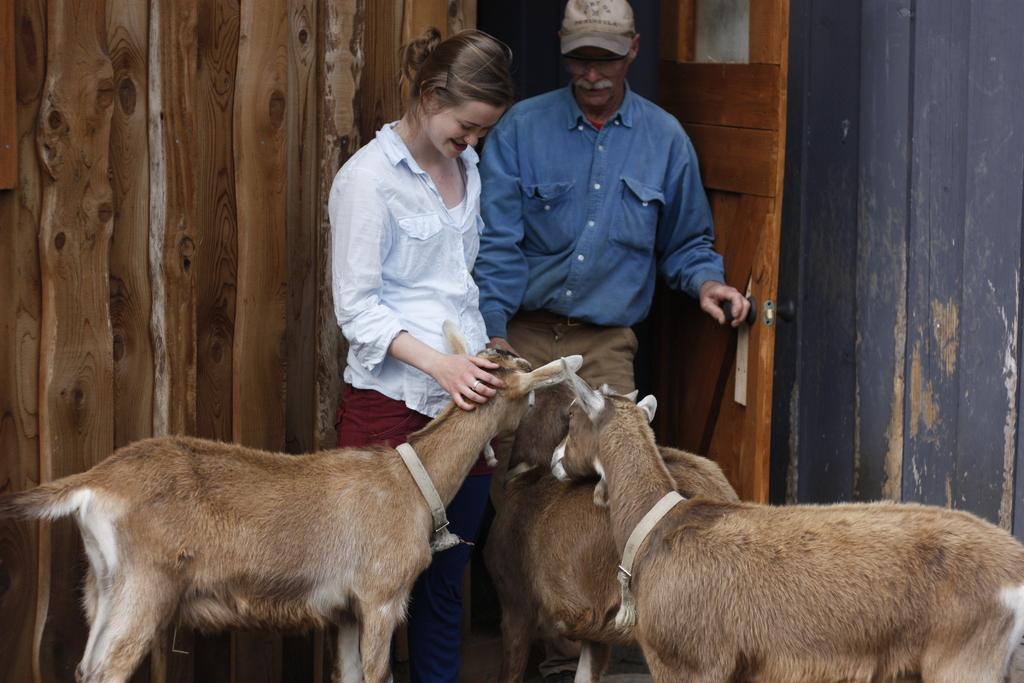Can you describe this image briefly? In this picture we can see a man and a woman standing and smiling, animals, caps, door and walls. 